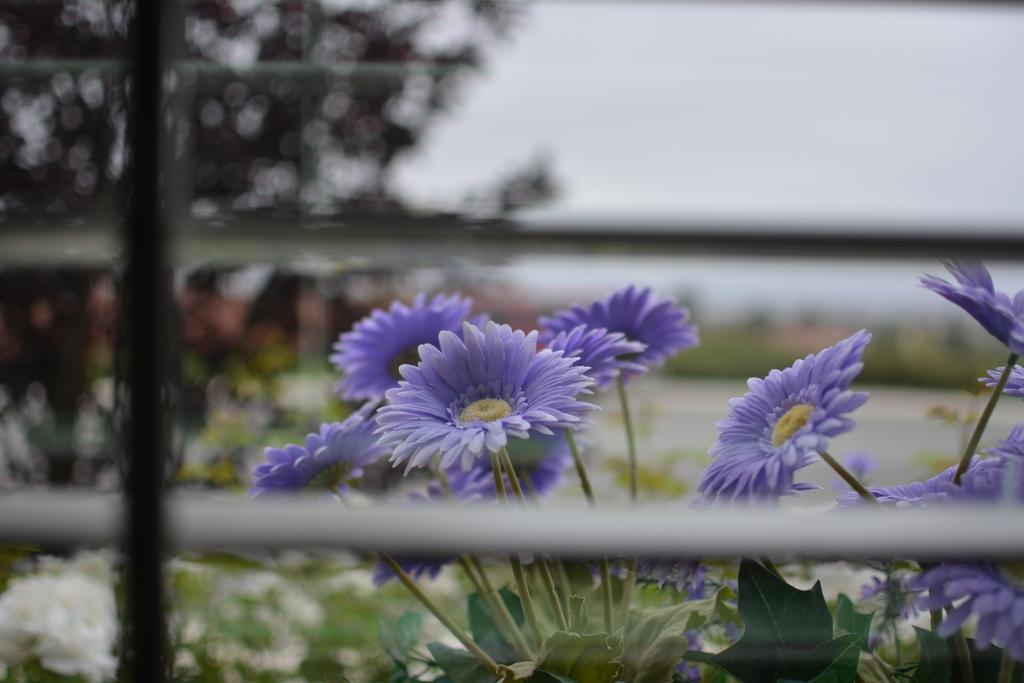What type of plants can be seen in the image? There are flowering plants in the image. What structure is present in the image? There is a fence in the image. What part of the natural environment is visible in the image? The sky is visible in the image. Where might this image have been taken? The image may have been taken in a garden, given the presence of flowering plants. What type of medical advice can be seen in the image? There is no medical advice present in the image; it features flowering plants, a fence, and the sky. What type of parenting advice can be seen in the image? There is no parenting advice present in the image; it features flowering plants, a fence, and the sky. 